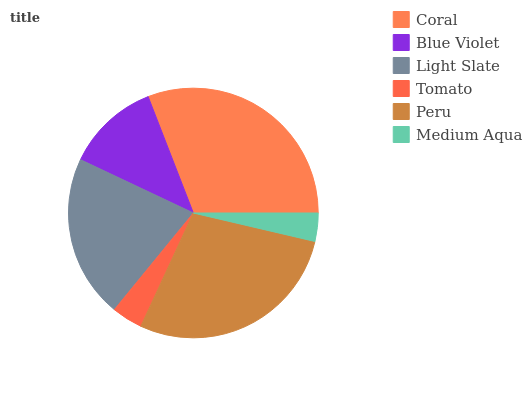Is Medium Aqua the minimum?
Answer yes or no. Yes. Is Coral the maximum?
Answer yes or no. Yes. Is Blue Violet the minimum?
Answer yes or no. No. Is Blue Violet the maximum?
Answer yes or no. No. Is Coral greater than Blue Violet?
Answer yes or no. Yes. Is Blue Violet less than Coral?
Answer yes or no. Yes. Is Blue Violet greater than Coral?
Answer yes or no. No. Is Coral less than Blue Violet?
Answer yes or no. No. Is Light Slate the high median?
Answer yes or no. Yes. Is Blue Violet the low median?
Answer yes or no. Yes. Is Tomato the high median?
Answer yes or no. No. Is Light Slate the low median?
Answer yes or no. No. 